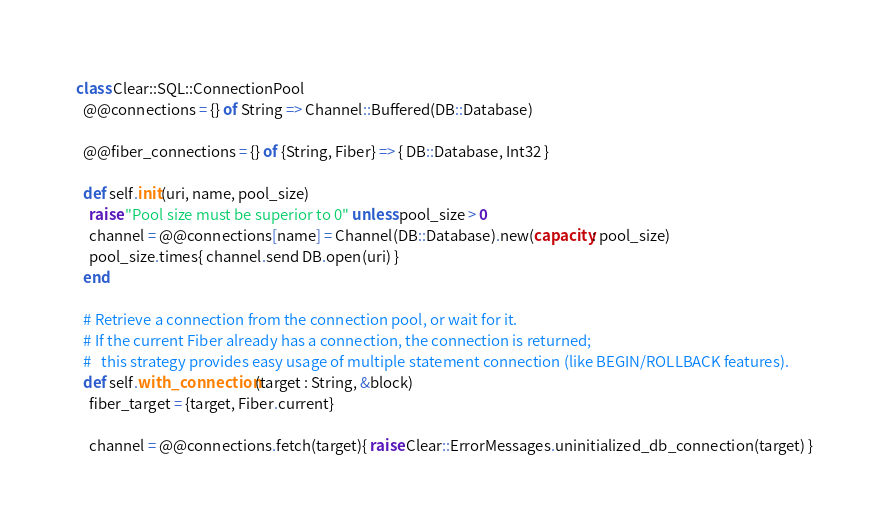<code> <loc_0><loc_0><loc_500><loc_500><_Crystal_>class Clear::SQL::ConnectionPool
  @@connections = {} of String => Channel::Buffered(DB::Database)

  @@fiber_connections = {} of {String, Fiber} => { DB::Database, Int32 }

  def self.init(uri, name, pool_size)
    raise "Pool size must be superior to 0" unless pool_size > 0
    channel = @@connections[name] = Channel(DB::Database).new(capacity: pool_size)
    pool_size.times{ channel.send DB.open(uri) }
  end

  # Retrieve a connection from the connection pool, or wait for it.
  # If the current Fiber already has a connection, the connection is returned;
  #   this strategy provides easy usage of multiple statement connection (like BEGIN/ROLLBACK features).
  def self.with_connection(target : String, &block)
    fiber_target = {target, Fiber.current}

    channel = @@connections.fetch(target){ raise Clear::ErrorMessages.uninitialized_db_connection(target) }</code> 